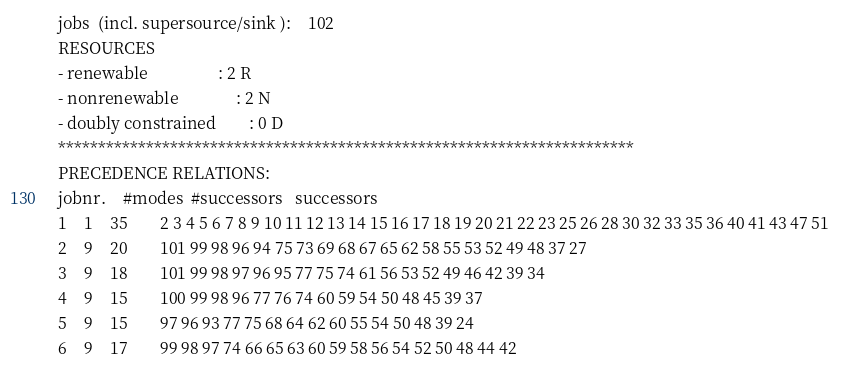<code> <loc_0><loc_0><loc_500><loc_500><_ObjectiveC_>jobs  (incl. supersource/sink ):	102
RESOURCES
- renewable                 : 2 R
- nonrenewable              : 2 N
- doubly constrained        : 0 D
************************************************************************
PRECEDENCE RELATIONS:
jobnr.    #modes  #successors   successors
1	1	35		2 3 4 5 6 7 8 9 10 11 12 13 14 15 16 17 18 19 20 21 22 23 25 26 28 30 32 33 35 36 40 41 43 47 51 
2	9	20		101 99 98 96 94 75 73 69 68 67 65 62 58 55 53 52 49 48 37 27 
3	9	18		101 99 98 97 96 95 77 75 74 61 56 53 52 49 46 42 39 34 
4	9	15		100 99 98 96 77 76 74 60 59 54 50 48 45 39 37 
5	9	15		97 96 93 77 75 68 64 62 60 55 54 50 48 39 24 
6	9	17		99 98 97 74 66 65 63 60 59 58 56 54 52 50 48 44 42 </code> 